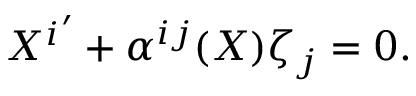Convert formula to latex. <formula><loc_0><loc_0><loc_500><loc_500>{ X ^ { i } } ^ { \prime } + \alpha ^ { i j } ( X ) \zeta _ { j } = 0 .</formula> 